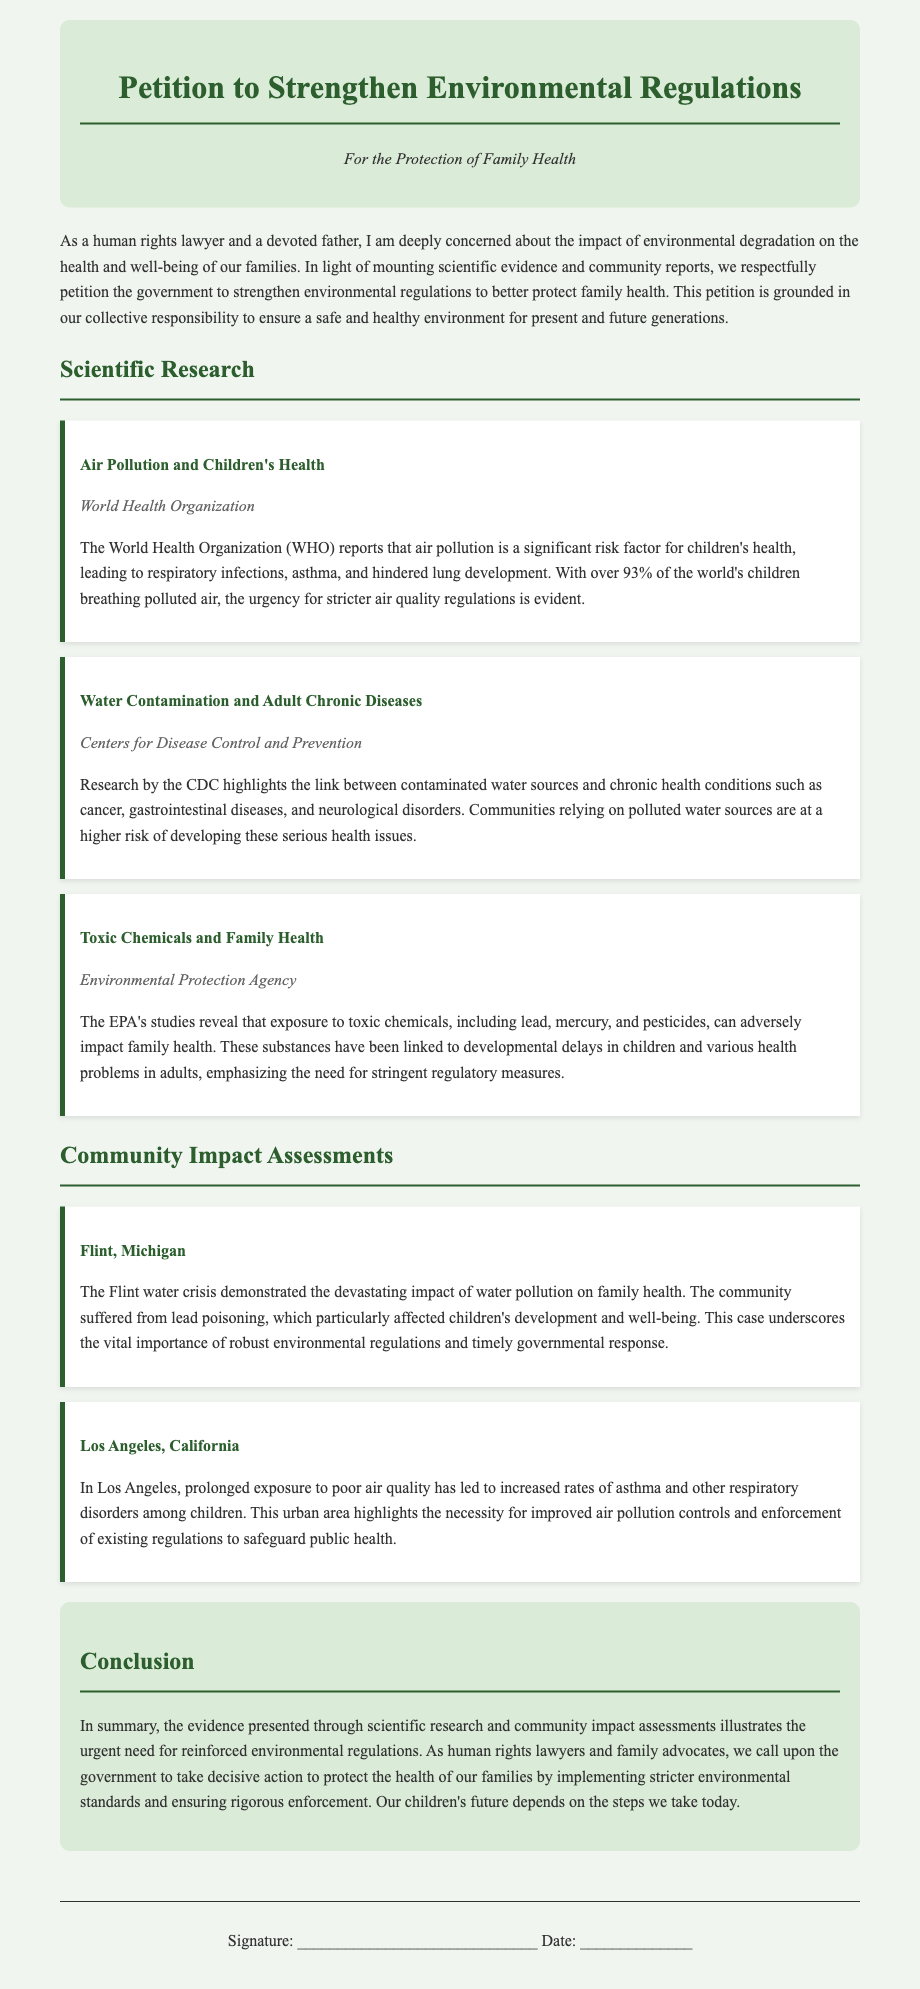What is the title of the petition? The title clearly states the purpose of the document, which is to strengthen environmental regulations.
Answer: Petition to Strengthen Environmental Regulations Who is the author of the petition? The petition mentions a role rather than an individual name, positioning the author as a concerned human rights lawyer and father.
Answer: a human rights lawyer What percentage of the world's children breathe polluted air? The document provides a statistic that highlights a significant global health issue affecting children.
Answer: over 93% Which organization reports on air pollution's impact on children's health? The document cites a prominent health organization, providing credibility to the claims made.
Answer: World Health Organization What crisis is referenced as an example of water pollution's impact on health? This case emphasizes the dire consequences of environmental neglect in a specific community.
Answer: Flint, Michigan What type of health conditions are linked to contaminated water sources according to the CDC? This highlights the grave health repercussions associated with water pollution as outlined by a major health institution.
Answer: chronic diseases What is the focus of the conclusion in the petition? The conclusion summarizes the evidence presented and calls for government action in a clear and direct manner.
Answer: urgent need for reinforced environmental regulations What is the color scheme of the petition's header? The color scheme is designed to create a soothing and serious tone for the document.
Answer: green and white 